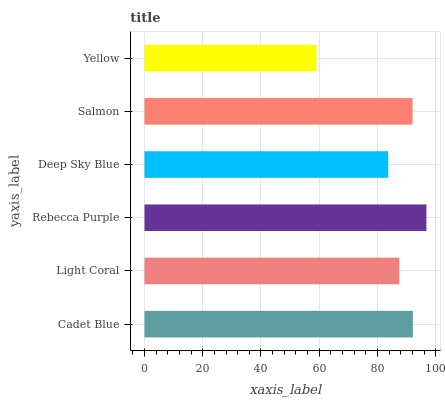Is Yellow the minimum?
Answer yes or no. Yes. Is Rebecca Purple the maximum?
Answer yes or no. Yes. Is Light Coral the minimum?
Answer yes or no. No. Is Light Coral the maximum?
Answer yes or no. No. Is Cadet Blue greater than Light Coral?
Answer yes or no. Yes. Is Light Coral less than Cadet Blue?
Answer yes or no. Yes. Is Light Coral greater than Cadet Blue?
Answer yes or no. No. Is Cadet Blue less than Light Coral?
Answer yes or no. No. Is Salmon the high median?
Answer yes or no. Yes. Is Light Coral the low median?
Answer yes or no. Yes. Is Rebecca Purple the high median?
Answer yes or no. No. Is Yellow the low median?
Answer yes or no. No. 